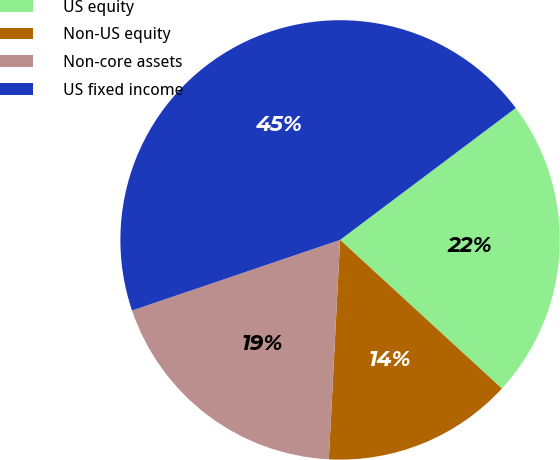Convert chart to OTSL. <chart><loc_0><loc_0><loc_500><loc_500><pie_chart><fcel>US equity<fcel>Non-US equity<fcel>Non-core assets<fcel>US fixed income<nl><fcel>22.08%<fcel>13.99%<fcel>18.98%<fcel>44.96%<nl></chart> 